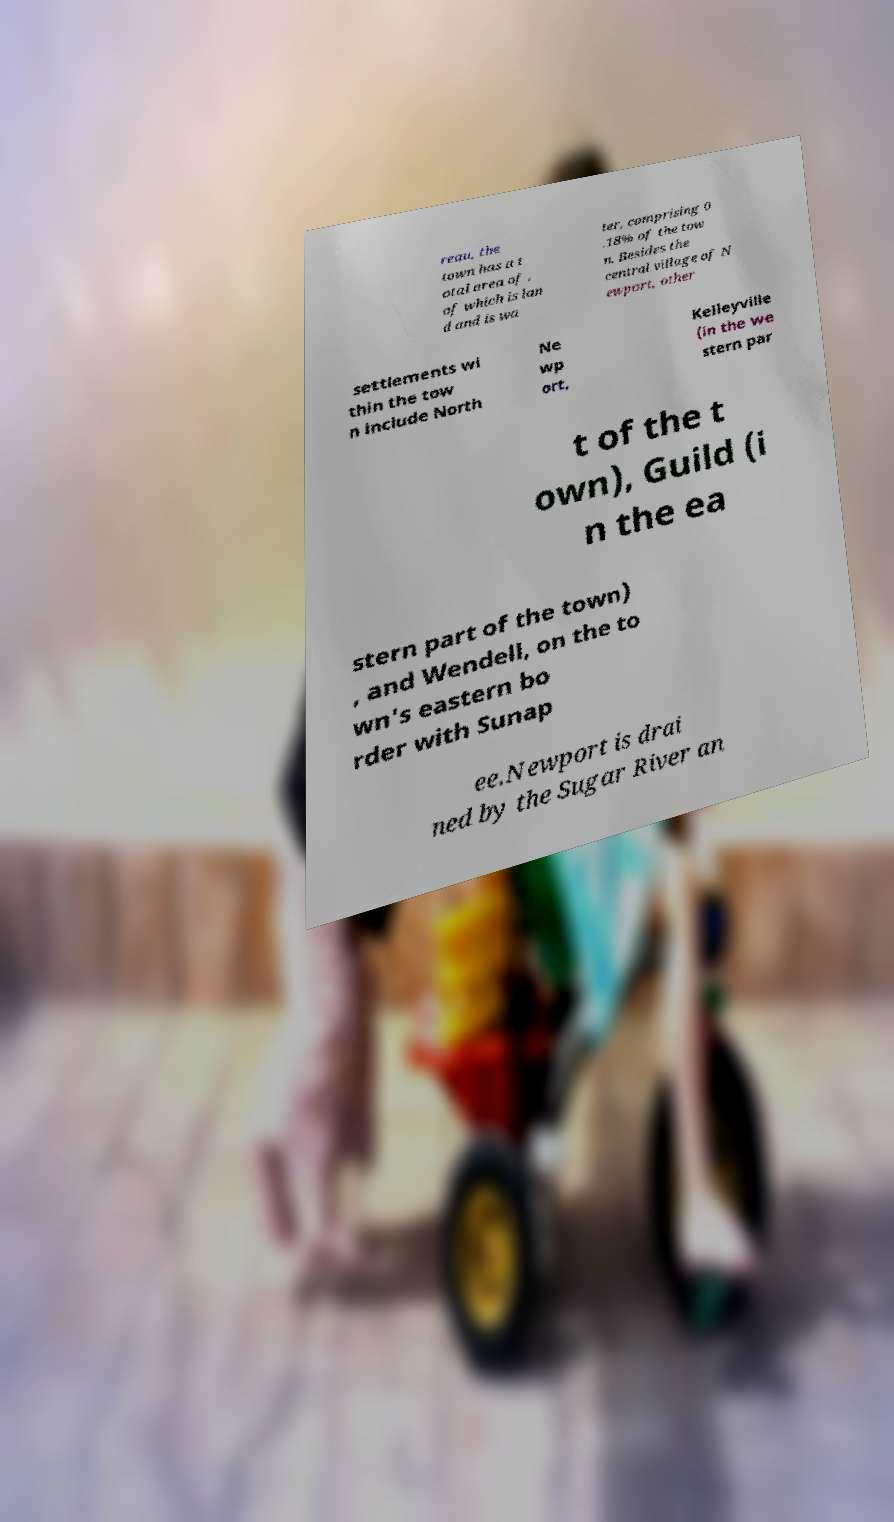What messages or text are displayed in this image? I need them in a readable, typed format. reau, the town has a t otal area of , of which is lan d and is wa ter, comprising 0 .18% of the tow n. Besides the central village of N ewport, other settlements wi thin the tow n include North Ne wp ort, Kelleyville (in the we stern par t of the t own), Guild (i n the ea stern part of the town) , and Wendell, on the to wn's eastern bo rder with Sunap ee.Newport is drai ned by the Sugar River an 